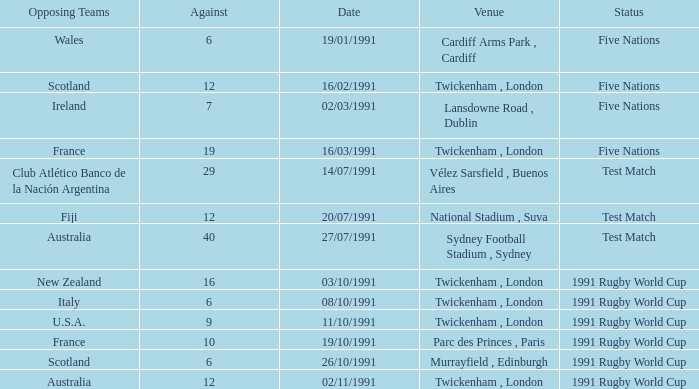What is Opposing Teams, when Date is "11/10/1991"? U.S.A. Can you parse all the data within this table? {'header': ['Opposing Teams', 'Against', 'Date', 'Venue', 'Status'], 'rows': [['Wales', '6', '19/01/1991', 'Cardiff Arms Park , Cardiff', 'Five Nations'], ['Scotland', '12', '16/02/1991', 'Twickenham , London', 'Five Nations'], ['Ireland', '7', '02/03/1991', 'Lansdowne Road , Dublin', 'Five Nations'], ['France', '19', '16/03/1991', 'Twickenham , London', 'Five Nations'], ['Club Atlético Banco de la Nación Argentina', '29', '14/07/1991', 'Vélez Sarsfield , Buenos Aires', 'Test Match'], ['Fiji', '12', '20/07/1991', 'National Stadium , Suva', 'Test Match'], ['Australia', '40', '27/07/1991', 'Sydney Football Stadium , Sydney', 'Test Match'], ['New Zealand', '16', '03/10/1991', 'Twickenham , London', '1991 Rugby World Cup'], ['Italy', '6', '08/10/1991', 'Twickenham , London', '1991 Rugby World Cup'], ['U.S.A.', '9', '11/10/1991', 'Twickenham , London', '1991 Rugby World Cup'], ['France', '10', '19/10/1991', 'Parc des Princes , Paris', '1991 Rugby World Cup'], ['Scotland', '6', '26/10/1991', 'Murrayfield , Edinburgh', '1991 Rugby World Cup'], ['Australia', '12', '02/11/1991', 'Twickenham , London', '1991 Rugby World Cup']]} 